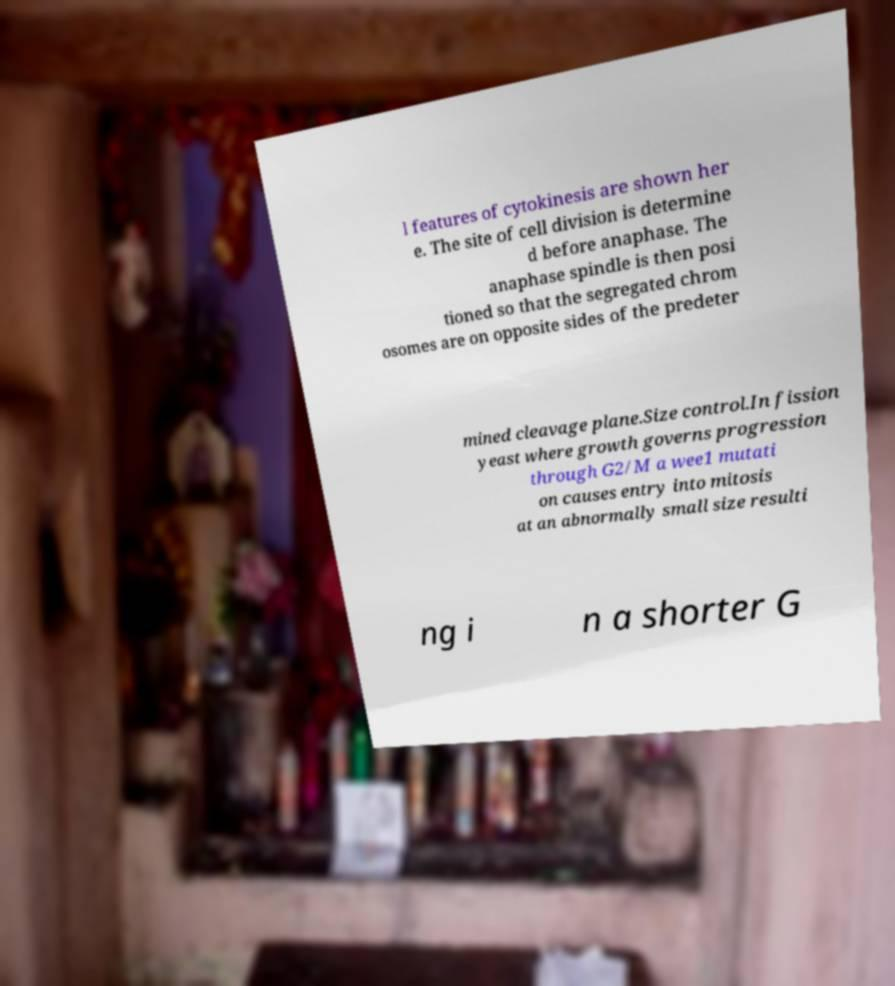What messages or text are displayed in this image? I need them in a readable, typed format. l features of cytokinesis are shown her e. The site of cell division is determine d before anaphase. The anaphase spindle is then posi tioned so that the segregated chrom osomes are on opposite sides of the predeter mined cleavage plane.Size control.In fission yeast where growth governs progression through G2/M a wee1 mutati on causes entry into mitosis at an abnormally small size resulti ng i n a shorter G 